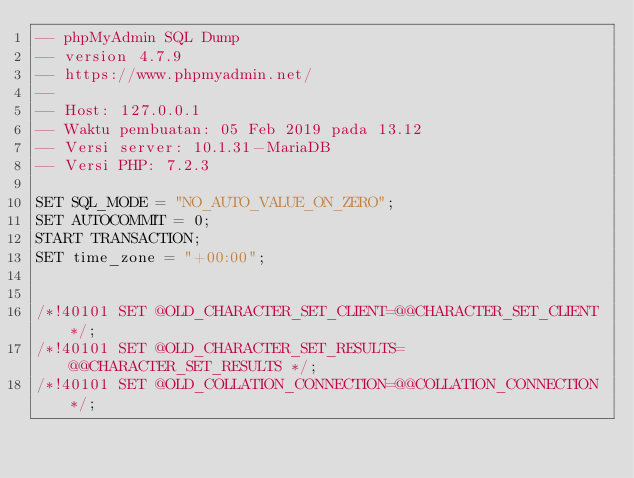<code> <loc_0><loc_0><loc_500><loc_500><_SQL_>-- phpMyAdmin SQL Dump
-- version 4.7.9
-- https://www.phpmyadmin.net/
--
-- Host: 127.0.0.1
-- Waktu pembuatan: 05 Feb 2019 pada 13.12
-- Versi server: 10.1.31-MariaDB
-- Versi PHP: 7.2.3

SET SQL_MODE = "NO_AUTO_VALUE_ON_ZERO";
SET AUTOCOMMIT = 0;
START TRANSACTION;
SET time_zone = "+00:00";


/*!40101 SET @OLD_CHARACTER_SET_CLIENT=@@CHARACTER_SET_CLIENT */;
/*!40101 SET @OLD_CHARACTER_SET_RESULTS=@@CHARACTER_SET_RESULTS */;
/*!40101 SET @OLD_COLLATION_CONNECTION=@@COLLATION_CONNECTION */;</code> 